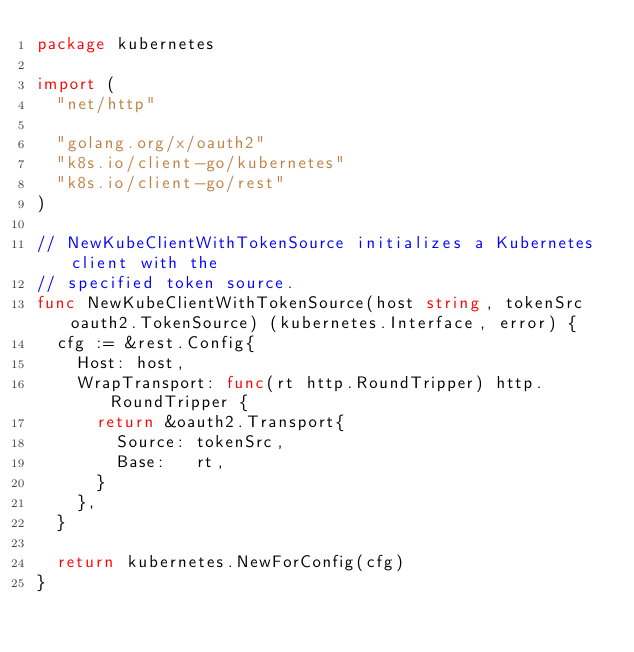Convert code to text. <code><loc_0><loc_0><loc_500><loc_500><_Go_>package kubernetes

import (
	"net/http"

	"golang.org/x/oauth2"
	"k8s.io/client-go/kubernetes"
	"k8s.io/client-go/rest"
)

// NewKubeClientWithTokenSource initializes a Kubernetes client with the
// specified token source.
func NewKubeClientWithTokenSource(host string, tokenSrc oauth2.TokenSource) (kubernetes.Interface, error) {
	cfg := &rest.Config{
		Host: host,
		WrapTransport: func(rt http.RoundTripper) http.RoundTripper {
			return &oauth2.Transport{
				Source: tokenSrc,
				Base:   rt,
			}
		},
	}

	return kubernetes.NewForConfig(cfg)
}
</code> 